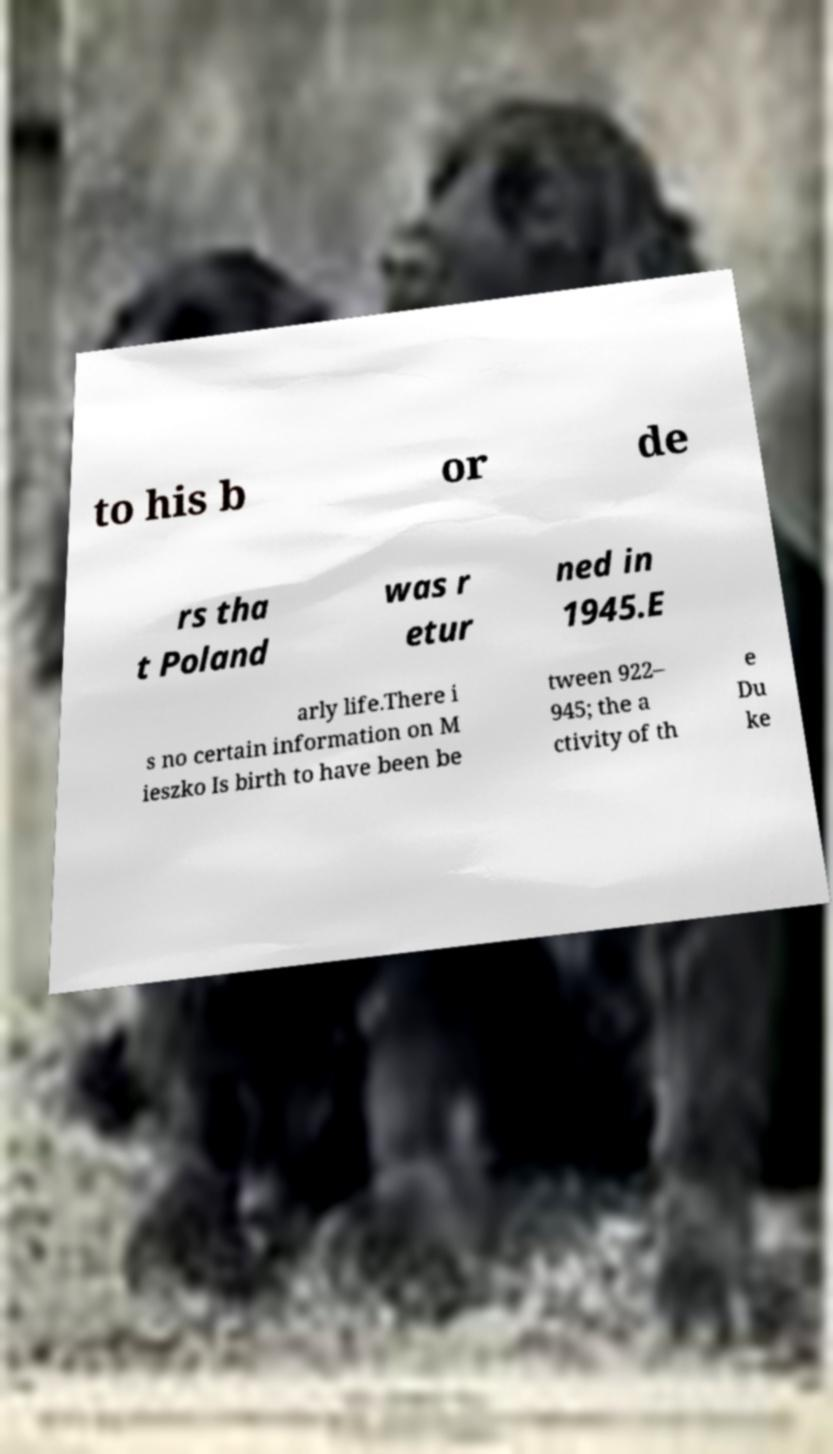Can you read and provide the text displayed in the image?This photo seems to have some interesting text. Can you extract and type it out for me? to his b or de rs tha t Poland was r etur ned in 1945.E arly life.There i s no certain information on M ieszko Is birth to have been be tween 922– 945; the a ctivity of th e Du ke 